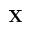Convert formula to latex. <formula><loc_0><loc_0><loc_500><loc_500>{ X }</formula> 